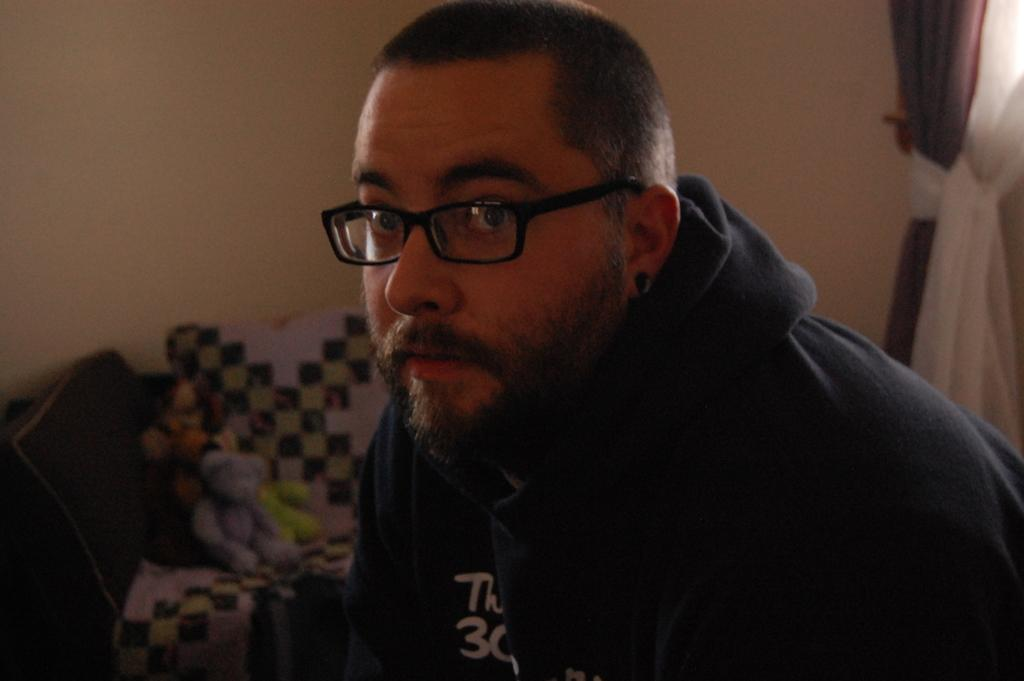What is the main subject of the picture? The main subject of the picture is a man. What is the man wearing on his face? The man is wearing sunglasses and spectacles. What can be seen on the chair in the picture? There are toys on a chair in the picture. What is present on the right side of the picture? There is a curtain on the right side of the picture. What is visible in the background of the picture? There is a wall in the background of the picture. How many cannons are present in the picture? There are no cannons present in the picture. What type of pickle is being used as a decoration on the wall? There is no pickle present in the picture, let alone being used as a decoration. 